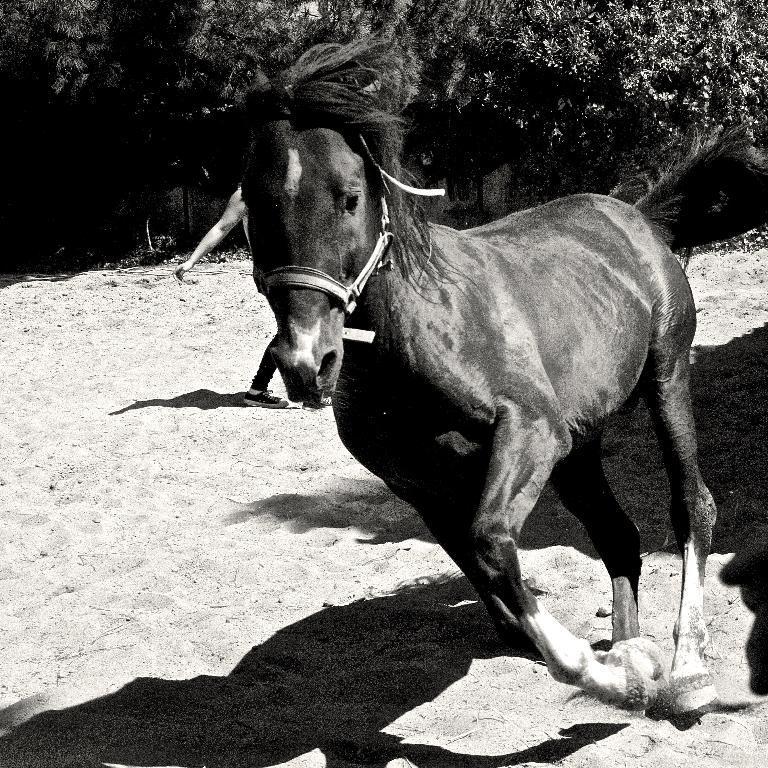Can you describe this image briefly? In this image I can see the black and white picture in which I can see a horse is standing on the sand. In the background I can see few trees and a person standing on the sand. 